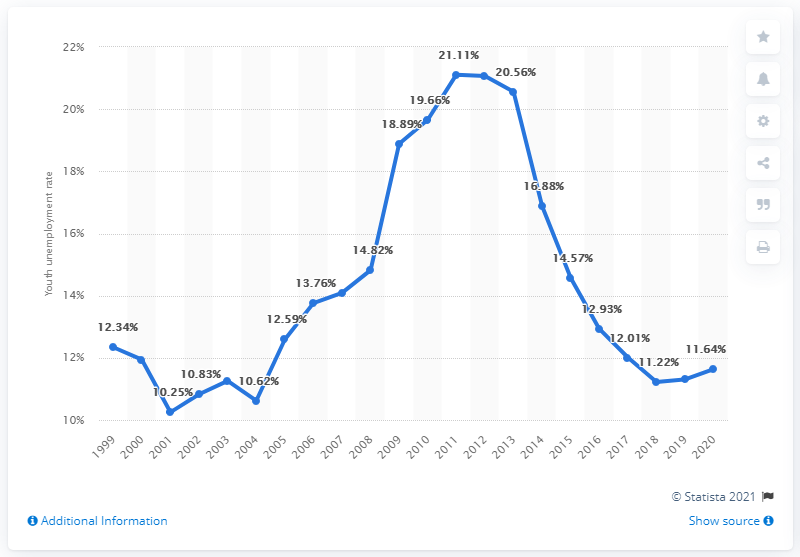Give some essential details in this illustration. In 2020, the youth unemployment rate in the UK was 11.64%. 